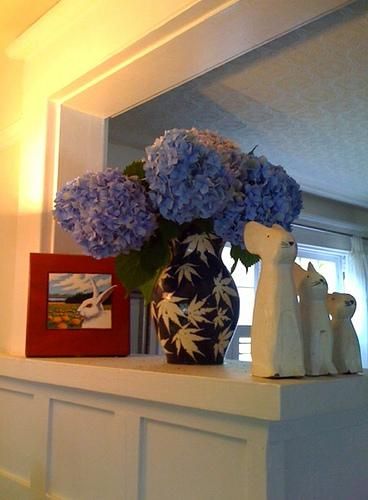Question: what color are the flowers?
Choices:
A. Blue.
B. Green.
C. Yellow.
D. Pink.
Answer with the letter. Answer: A Question: what is to the left of the vase?
Choices:
A. A drawing.
B. Painting.
C. Poster.
D. Flowers.
Answer with the letter. Answer: A Question: how many rabbits in the drawing on the shelf?
Choices:
A. One.
B. Four.
C. Five.
D. Ten.
Answer with the letter. Answer: A Question: how many rabbit figurines are there?
Choices:
A. Twenty five.
B. Seven.
C. Three.
D. Ten.
Answer with the letter. Answer: C 